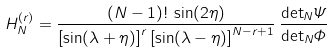<formula> <loc_0><loc_0><loc_500><loc_500>H _ { N } ^ { ( r ) } = \frac { ( N - 1 ) ! \, \sin ( 2 \eta ) } { \left [ \sin ( \lambda + \eta ) \right ] ^ { r } \left [ \sin ( \lambda - \eta ) \right ] ^ { N - r + 1 } } \, \frac { { \det } _ { N } \varPsi } { { \det } _ { N } \varPhi }</formula> 